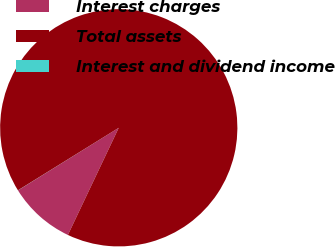Convert chart. <chart><loc_0><loc_0><loc_500><loc_500><pie_chart><fcel>Interest charges<fcel>Total assets<fcel>Interest and dividend income<nl><fcel>9.1%<fcel>90.89%<fcel>0.01%<nl></chart> 